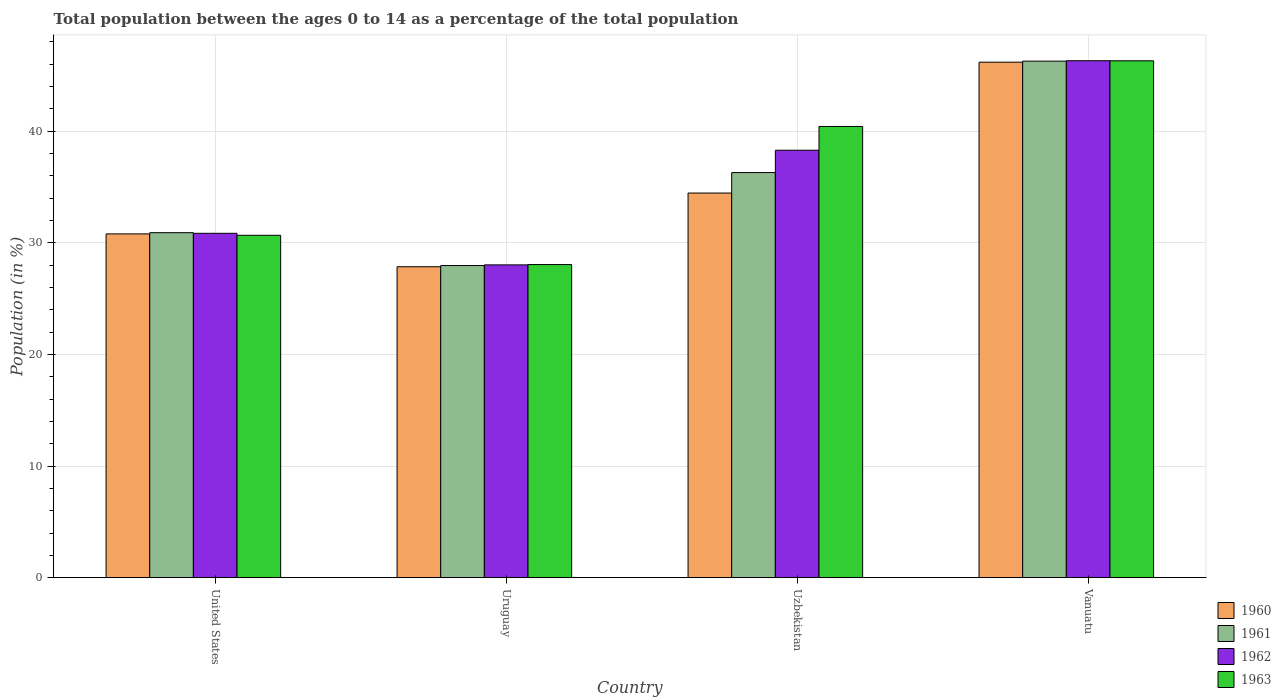How many groups of bars are there?
Ensure brevity in your answer.  4. Are the number of bars on each tick of the X-axis equal?
Provide a short and direct response. Yes. How many bars are there on the 3rd tick from the right?
Provide a short and direct response. 4. In how many cases, is the number of bars for a given country not equal to the number of legend labels?
Your response must be concise. 0. What is the percentage of the population ages 0 to 14 in 1963 in Uzbekistan?
Provide a succinct answer. 40.43. Across all countries, what is the maximum percentage of the population ages 0 to 14 in 1960?
Give a very brief answer. 46.19. Across all countries, what is the minimum percentage of the population ages 0 to 14 in 1960?
Provide a short and direct response. 27.86. In which country was the percentage of the population ages 0 to 14 in 1960 maximum?
Provide a succinct answer. Vanuatu. In which country was the percentage of the population ages 0 to 14 in 1962 minimum?
Your response must be concise. Uruguay. What is the total percentage of the population ages 0 to 14 in 1963 in the graph?
Your response must be concise. 145.47. What is the difference between the percentage of the population ages 0 to 14 in 1962 in United States and that in Vanuatu?
Provide a succinct answer. -15.46. What is the difference between the percentage of the population ages 0 to 14 in 1960 in Uzbekistan and the percentage of the population ages 0 to 14 in 1962 in Uruguay?
Provide a succinct answer. 6.43. What is the average percentage of the population ages 0 to 14 in 1962 per country?
Your answer should be compact. 35.87. What is the difference between the percentage of the population ages 0 to 14 of/in 1961 and percentage of the population ages 0 to 14 of/in 1960 in Vanuatu?
Provide a short and direct response. 0.09. What is the ratio of the percentage of the population ages 0 to 14 in 1961 in United States to that in Uzbekistan?
Ensure brevity in your answer.  0.85. Is the percentage of the population ages 0 to 14 in 1963 in Uzbekistan less than that in Vanuatu?
Keep it short and to the point. Yes. Is the difference between the percentage of the population ages 0 to 14 in 1961 in United States and Uruguay greater than the difference between the percentage of the population ages 0 to 14 in 1960 in United States and Uruguay?
Provide a short and direct response. Yes. What is the difference between the highest and the second highest percentage of the population ages 0 to 14 in 1960?
Keep it short and to the point. -11.73. What is the difference between the highest and the lowest percentage of the population ages 0 to 14 in 1962?
Your response must be concise. 18.29. Is the sum of the percentage of the population ages 0 to 14 in 1962 in United States and Vanuatu greater than the maximum percentage of the population ages 0 to 14 in 1960 across all countries?
Your answer should be compact. Yes. Is it the case that in every country, the sum of the percentage of the population ages 0 to 14 in 1963 and percentage of the population ages 0 to 14 in 1960 is greater than the sum of percentage of the population ages 0 to 14 in 1962 and percentage of the population ages 0 to 14 in 1961?
Offer a very short reply. No. Is it the case that in every country, the sum of the percentage of the population ages 0 to 14 in 1960 and percentage of the population ages 0 to 14 in 1963 is greater than the percentage of the population ages 0 to 14 in 1962?
Your response must be concise. Yes. How many countries are there in the graph?
Provide a succinct answer. 4. Are the values on the major ticks of Y-axis written in scientific E-notation?
Keep it short and to the point. No. How many legend labels are there?
Provide a succinct answer. 4. How are the legend labels stacked?
Give a very brief answer. Vertical. What is the title of the graph?
Your answer should be compact. Total population between the ages 0 to 14 as a percentage of the total population. Does "1994" appear as one of the legend labels in the graph?
Your answer should be compact. No. What is the label or title of the X-axis?
Make the answer very short. Country. What is the label or title of the Y-axis?
Give a very brief answer. Population (in %). What is the Population (in %) in 1960 in United States?
Ensure brevity in your answer.  30.8. What is the Population (in %) of 1961 in United States?
Provide a short and direct response. 30.91. What is the Population (in %) in 1962 in United States?
Your answer should be very brief. 30.86. What is the Population (in %) in 1963 in United States?
Keep it short and to the point. 30.68. What is the Population (in %) of 1960 in Uruguay?
Provide a succinct answer. 27.86. What is the Population (in %) in 1961 in Uruguay?
Offer a terse response. 27.97. What is the Population (in %) in 1962 in Uruguay?
Your response must be concise. 28.03. What is the Population (in %) of 1963 in Uruguay?
Your answer should be very brief. 28.05. What is the Population (in %) in 1960 in Uzbekistan?
Ensure brevity in your answer.  34.46. What is the Population (in %) of 1961 in Uzbekistan?
Give a very brief answer. 36.3. What is the Population (in %) of 1962 in Uzbekistan?
Offer a very short reply. 38.3. What is the Population (in %) of 1963 in Uzbekistan?
Your answer should be very brief. 40.43. What is the Population (in %) of 1960 in Vanuatu?
Provide a short and direct response. 46.19. What is the Population (in %) in 1961 in Vanuatu?
Ensure brevity in your answer.  46.28. What is the Population (in %) of 1962 in Vanuatu?
Your response must be concise. 46.32. What is the Population (in %) in 1963 in Vanuatu?
Your answer should be very brief. 46.31. Across all countries, what is the maximum Population (in %) in 1960?
Keep it short and to the point. 46.19. Across all countries, what is the maximum Population (in %) in 1961?
Make the answer very short. 46.28. Across all countries, what is the maximum Population (in %) of 1962?
Ensure brevity in your answer.  46.32. Across all countries, what is the maximum Population (in %) of 1963?
Your response must be concise. 46.31. Across all countries, what is the minimum Population (in %) of 1960?
Your response must be concise. 27.86. Across all countries, what is the minimum Population (in %) in 1961?
Make the answer very short. 27.97. Across all countries, what is the minimum Population (in %) in 1962?
Offer a terse response. 28.03. Across all countries, what is the minimum Population (in %) of 1963?
Give a very brief answer. 28.05. What is the total Population (in %) of 1960 in the graph?
Make the answer very short. 139.31. What is the total Population (in %) in 1961 in the graph?
Offer a terse response. 141.46. What is the total Population (in %) of 1962 in the graph?
Provide a succinct answer. 143.5. What is the total Population (in %) in 1963 in the graph?
Give a very brief answer. 145.47. What is the difference between the Population (in %) in 1960 in United States and that in Uruguay?
Your response must be concise. 2.94. What is the difference between the Population (in %) in 1961 in United States and that in Uruguay?
Your answer should be very brief. 2.94. What is the difference between the Population (in %) in 1962 in United States and that in Uruguay?
Make the answer very short. 2.83. What is the difference between the Population (in %) of 1963 in United States and that in Uruguay?
Provide a short and direct response. 2.62. What is the difference between the Population (in %) in 1960 in United States and that in Uzbekistan?
Keep it short and to the point. -3.66. What is the difference between the Population (in %) in 1961 in United States and that in Uzbekistan?
Ensure brevity in your answer.  -5.39. What is the difference between the Population (in %) in 1962 in United States and that in Uzbekistan?
Provide a short and direct response. -7.44. What is the difference between the Population (in %) of 1963 in United States and that in Uzbekistan?
Offer a terse response. -9.75. What is the difference between the Population (in %) in 1960 in United States and that in Vanuatu?
Your answer should be compact. -15.38. What is the difference between the Population (in %) in 1961 in United States and that in Vanuatu?
Give a very brief answer. -15.37. What is the difference between the Population (in %) of 1962 in United States and that in Vanuatu?
Keep it short and to the point. -15.46. What is the difference between the Population (in %) of 1963 in United States and that in Vanuatu?
Provide a short and direct response. -15.63. What is the difference between the Population (in %) of 1960 in Uruguay and that in Uzbekistan?
Ensure brevity in your answer.  -6.6. What is the difference between the Population (in %) in 1961 in Uruguay and that in Uzbekistan?
Make the answer very short. -8.33. What is the difference between the Population (in %) of 1962 in Uruguay and that in Uzbekistan?
Give a very brief answer. -10.27. What is the difference between the Population (in %) of 1963 in Uruguay and that in Uzbekistan?
Ensure brevity in your answer.  -12.37. What is the difference between the Population (in %) of 1960 in Uruguay and that in Vanuatu?
Ensure brevity in your answer.  -18.33. What is the difference between the Population (in %) in 1961 in Uruguay and that in Vanuatu?
Ensure brevity in your answer.  -18.31. What is the difference between the Population (in %) in 1962 in Uruguay and that in Vanuatu?
Keep it short and to the point. -18.29. What is the difference between the Population (in %) of 1963 in Uruguay and that in Vanuatu?
Offer a terse response. -18.26. What is the difference between the Population (in %) in 1960 in Uzbekistan and that in Vanuatu?
Offer a very short reply. -11.73. What is the difference between the Population (in %) in 1961 in Uzbekistan and that in Vanuatu?
Provide a short and direct response. -9.98. What is the difference between the Population (in %) of 1962 in Uzbekistan and that in Vanuatu?
Keep it short and to the point. -8.02. What is the difference between the Population (in %) in 1963 in Uzbekistan and that in Vanuatu?
Offer a very short reply. -5.88. What is the difference between the Population (in %) of 1960 in United States and the Population (in %) of 1961 in Uruguay?
Provide a succinct answer. 2.84. What is the difference between the Population (in %) of 1960 in United States and the Population (in %) of 1962 in Uruguay?
Give a very brief answer. 2.78. What is the difference between the Population (in %) of 1960 in United States and the Population (in %) of 1963 in Uruguay?
Ensure brevity in your answer.  2.75. What is the difference between the Population (in %) of 1961 in United States and the Population (in %) of 1962 in Uruguay?
Ensure brevity in your answer.  2.88. What is the difference between the Population (in %) in 1961 in United States and the Population (in %) in 1963 in Uruguay?
Provide a short and direct response. 2.86. What is the difference between the Population (in %) of 1962 in United States and the Population (in %) of 1963 in Uruguay?
Offer a terse response. 2.8. What is the difference between the Population (in %) in 1960 in United States and the Population (in %) in 1961 in Uzbekistan?
Your answer should be very brief. -5.49. What is the difference between the Population (in %) in 1960 in United States and the Population (in %) in 1962 in Uzbekistan?
Your response must be concise. -7.5. What is the difference between the Population (in %) of 1960 in United States and the Population (in %) of 1963 in Uzbekistan?
Give a very brief answer. -9.62. What is the difference between the Population (in %) in 1961 in United States and the Population (in %) in 1962 in Uzbekistan?
Ensure brevity in your answer.  -7.39. What is the difference between the Population (in %) in 1961 in United States and the Population (in %) in 1963 in Uzbekistan?
Make the answer very short. -9.52. What is the difference between the Population (in %) in 1962 in United States and the Population (in %) in 1963 in Uzbekistan?
Your response must be concise. -9.57. What is the difference between the Population (in %) in 1960 in United States and the Population (in %) in 1961 in Vanuatu?
Ensure brevity in your answer.  -15.48. What is the difference between the Population (in %) in 1960 in United States and the Population (in %) in 1962 in Vanuatu?
Your answer should be compact. -15.51. What is the difference between the Population (in %) of 1960 in United States and the Population (in %) of 1963 in Vanuatu?
Keep it short and to the point. -15.51. What is the difference between the Population (in %) of 1961 in United States and the Population (in %) of 1962 in Vanuatu?
Your answer should be compact. -15.41. What is the difference between the Population (in %) of 1961 in United States and the Population (in %) of 1963 in Vanuatu?
Your answer should be compact. -15.4. What is the difference between the Population (in %) in 1962 in United States and the Population (in %) in 1963 in Vanuatu?
Offer a terse response. -15.46. What is the difference between the Population (in %) in 1960 in Uruguay and the Population (in %) in 1961 in Uzbekistan?
Your answer should be very brief. -8.44. What is the difference between the Population (in %) in 1960 in Uruguay and the Population (in %) in 1962 in Uzbekistan?
Provide a succinct answer. -10.44. What is the difference between the Population (in %) in 1960 in Uruguay and the Population (in %) in 1963 in Uzbekistan?
Give a very brief answer. -12.57. What is the difference between the Population (in %) in 1961 in Uruguay and the Population (in %) in 1962 in Uzbekistan?
Give a very brief answer. -10.33. What is the difference between the Population (in %) in 1961 in Uruguay and the Population (in %) in 1963 in Uzbekistan?
Offer a very short reply. -12.46. What is the difference between the Population (in %) in 1962 in Uruguay and the Population (in %) in 1963 in Uzbekistan?
Ensure brevity in your answer.  -12.4. What is the difference between the Population (in %) of 1960 in Uruguay and the Population (in %) of 1961 in Vanuatu?
Your answer should be very brief. -18.42. What is the difference between the Population (in %) of 1960 in Uruguay and the Population (in %) of 1962 in Vanuatu?
Your answer should be very brief. -18.46. What is the difference between the Population (in %) of 1960 in Uruguay and the Population (in %) of 1963 in Vanuatu?
Your answer should be very brief. -18.45. What is the difference between the Population (in %) of 1961 in Uruguay and the Population (in %) of 1962 in Vanuatu?
Your answer should be very brief. -18.35. What is the difference between the Population (in %) of 1961 in Uruguay and the Population (in %) of 1963 in Vanuatu?
Offer a terse response. -18.34. What is the difference between the Population (in %) in 1962 in Uruguay and the Population (in %) in 1963 in Vanuatu?
Provide a succinct answer. -18.28. What is the difference between the Population (in %) of 1960 in Uzbekistan and the Population (in %) of 1961 in Vanuatu?
Your answer should be compact. -11.82. What is the difference between the Population (in %) in 1960 in Uzbekistan and the Population (in %) in 1962 in Vanuatu?
Keep it short and to the point. -11.86. What is the difference between the Population (in %) in 1960 in Uzbekistan and the Population (in %) in 1963 in Vanuatu?
Offer a very short reply. -11.85. What is the difference between the Population (in %) of 1961 in Uzbekistan and the Population (in %) of 1962 in Vanuatu?
Offer a very short reply. -10.02. What is the difference between the Population (in %) of 1961 in Uzbekistan and the Population (in %) of 1963 in Vanuatu?
Ensure brevity in your answer.  -10.01. What is the difference between the Population (in %) in 1962 in Uzbekistan and the Population (in %) in 1963 in Vanuatu?
Give a very brief answer. -8.01. What is the average Population (in %) of 1960 per country?
Ensure brevity in your answer.  34.83. What is the average Population (in %) in 1961 per country?
Offer a very short reply. 35.36. What is the average Population (in %) in 1962 per country?
Your answer should be compact. 35.87. What is the average Population (in %) of 1963 per country?
Keep it short and to the point. 36.37. What is the difference between the Population (in %) in 1960 and Population (in %) in 1961 in United States?
Keep it short and to the point. -0.11. What is the difference between the Population (in %) of 1960 and Population (in %) of 1962 in United States?
Make the answer very short. -0.05. What is the difference between the Population (in %) in 1960 and Population (in %) in 1963 in United States?
Keep it short and to the point. 0.13. What is the difference between the Population (in %) in 1961 and Population (in %) in 1962 in United States?
Your answer should be very brief. 0.06. What is the difference between the Population (in %) in 1961 and Population (in %) in 1963 in United States?
Make the answer very short. 0.23. What is the difference between the Population (in %) of 1962 and Population (in %) of 1963 in United States?
Provide a short and direct response. 0.18. What is the difference between the Population (in %) in 1960 and Population (in %) in 1961 in Uruguay?
Give a very brief answer. -0.11. What is the difference between the Population (in %) of 1960 and Population (in %) of 1962 in Uruguay?
Make the answer very short. -0.17. What is the difference between the Population (in %) of 1960 and Population (in %) of 1963 in Uruguay?
Your answer should be very brief. -0.19. What is the difference between the Population (in %) in 1961 and Population (in %) in 1962 in Uruguay?
Offer a terse response. -0.06. What is the difference between the Population (in %) in 1961 and Population (in %) in 1963 in Uruguay?
Your response must be concise. -0.09. What is the difference between the Population (in %) of 1962 and Population (in %) of 1963 in Uruguay?
Give a very brief answer. -0.03. What is the difference between the Population (in %) in 1960 and Population (in %) in 1961 in Uzbekistan?
Your answer should be very brief. -1.84. What is the difference between the Population (in %) of 1960 and Population (in %) of 1962 in Uzbekistan?
Offer a terse response. -3.84. What is the difference between the Population (in %) in 1960 and Population (in %) in 1963 in Uzbekistan?
Keep it short and to the point. -5.97. What is the difference between the Population (in %) of 1961 and Population (in %) of 1962 in Uzbekistan?
Offer a very short reply. -2. What is the difference between the Population (in %) of 1961 and Population (in %) of 1963 in Uzbekistan?
Your answer should be compact. -4.13. What is the difference between the Population (in %) in 1962 and Population (in %) in 1963 in Uzbekistan?
Your response must be concise. -2.13. What is the difference between the Population (in %) in 1960 and Population (in %) in 1961 in Vanuatu?
Keep it short and to the point. -0.09. What is the difference between the Population (in %) in 1960 and Population (in %) in 1962 in Vanuatu?
Give a very brief answer. -0.13. What is the difference between the Population (in %) in 1960 and Population (in %) in 1963 in Vanuatu?
Keep it short and to the point. -0.12. What is the difference between the Population (in %) in 1961 and Population (in %) in 1962 in Vanuatu?
Make the answer very short. -0.04. What is the difference between the Population (in %) of 1961 and Population (in %) of 1963 in Vanuatu?
Keep it short and to the point. -0.03. What is the difference between the Population (in %) of 1962 and Population (in %) of 1963 in Vanuatu?
Your response must be concise. 0.01. What is the ratio of the Population (in %) of 1960 in United States to that in Uruguay?
Give a very brief answer. 1.11. What is the ratio of the Population (in %) in 1961 in United States to that in Uruguay?
Your answer should be compact. 1.11. What is the ratio of the Population (in %) in 1962 in United States to that in Uruguay?
Give a very brief answer. 1.1. What is the ratio of the Population (in %) of 1963 in United States to that in Uruguay?
Provide a succinct answer. 1.09. What is the ratio of the Population (in %) of 1960 in United States to that in Uzbekistan?
Ensure brevity in your answer.  0.89. What is the ratio of the Population (in %) in 1961 in United States to that in Uzbekistan?
Provide a short and direct response. 0.85. What is the ratio of the Population (in %) in 1962 in United States to that in Uzbekistan?
Offer a terse response. 0.81. What is the ratio of the Population (in %) of 1963 in United States to that in Uzbekistan?
Your response must be concise. 0.76. What is the ratio of the Population (in %) of 1960 in United States to that in Vanuatu?
Offer a very short reply. 0.67. What is the ratio of the Population (in %) in 1961 in United States to that in Vanuatu?
Offer a very short reply. 0.67. What is the ratio of the Population (in %) in 1962 in United States to that in Vanuatu?
Provide a succinct answer. 0.67. What is the ratio of the Population (in %) in 1963 in United States to that in Vanuatu?
Offer a terse response. 0.66. What is the ratio of the Population (in %) of 1960 in Uruguay to that in Uzbekistan?
Ensure brevity in your answer.  0.81. What is the ratio of the Population (in %) of 1961 in Uruguay to that in Uzbekistan?
Give a very brief answer. 0.77. What is the ratio of the Population (in %) in 1962 in Uruguay to that in Uzbekistan?
Provide a short and direct response. 0.73. What is the ratio of the Population (in %) in 1963 in Uruguay to that in Uzbekistan?
Give a very brief answer. 0.69. What is the ratio of the Population (in %) of 1960 in Uruguay to that in Vanuatu?
Provide a short and direct response. 0.6. What is the ratio of the Population (in %) in 1961 in Uruguay to that in Vanuatu?
Ensure brevity in your answer.  0.6. What is the ratio of the Population (in %) of 1962 in Uruguay to that in Vanuatu?
Your answer should be compact. 0.61. What is the ratio of the Population (in %) in 1963 in Uruguay to that in Vanuatu?
Ensure brevity in your answer.  0.61. What is the ratio of the Population (in %) in 1960 in Uzbekistan to that in Vanuatu?
Offer a very short reply. 0.75. What is the ratio of the Population (in %) of 1961 in Uzbekistan to that in Vanuatu?
Ensure brevity in your answer.  0.78. What is the ratio of the Population (in %) of 1962 in Uzbekistan to that in Vanuatu?
Provide a succinct answer. 0.83. What is the ratio of the Population (in %) in 1963 in Uzbekistan to that in Vanuatu?
Your answer should be very brief. 0.87. What is the difference between the highest and the second highest Population (in %) in 1960?
Provide a succinct answer. 11.73. What is the difference between the highest and the second highest Population (in %) of 1961?
Make the answer very short. 9.98. What is the difference between the highest and the second highest Population (in %) in 1962?
Keep it short and to the point. 8.02. What is the difference between the highest and the second highest Population (in %) in 1963?
Make the answer very short. 5.88. What is the difference between the highest and the lowest Population (in %) in 1960?
Keep it short and to the point. 18.33. What is the difference between the highest and the lowest Population (in %) in 1961?
Offer a terse response. 18.31. What is the difference between the highest and the lowest Population (in %) in 1962?
Give a very brief answer. 18.29. What is the difference between the highest and the lowest Population (in %) of 1963?
Provide a succinct answer. 18.26. 